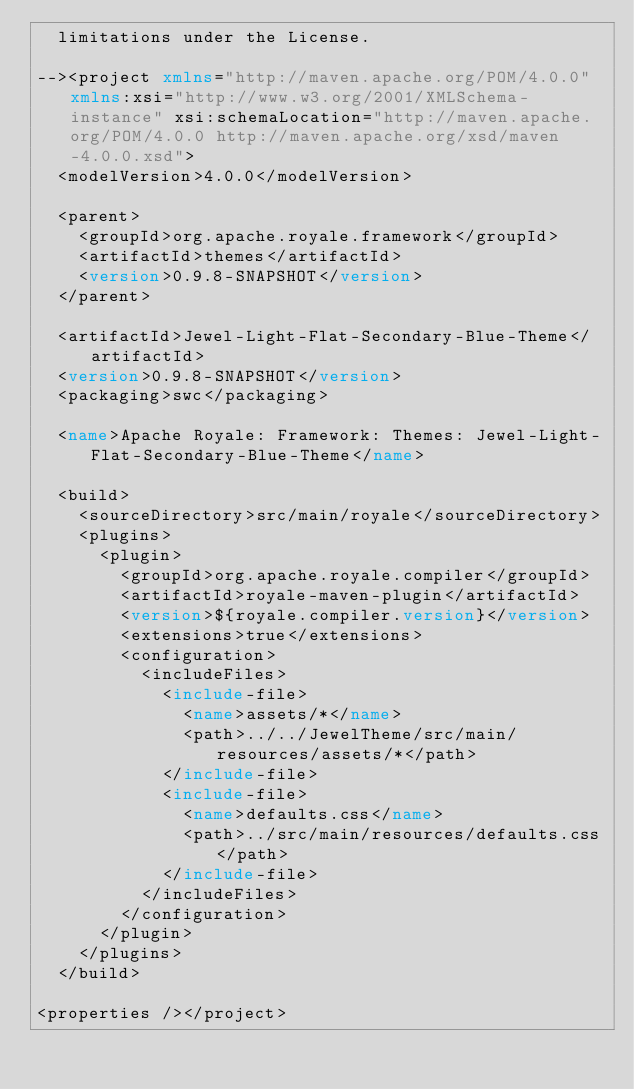<code> <loc_0><loc_0><loc_500><loc_500><_XML_>  limitations under the License.

--><project xmlns="http://maven.apache.org/POM/4.0.0" xmlns:xsi="http://www.w3.org/2001/XMLSchema-instance" xsi:schemaLocation="http://maven.apache.org/POM/4.0.0 http://maven.apache.org/xsd/maven-4.0.0.xsd">
  <modelVersion>4.0.0</modelVersion>

  <parent>
    <groupId>org.apache.royale.framework</groupId>
    <artifactId>themes</artifactId>
    <version>0.9.8-SNAPSHOT</version>
  </parent>

  <artifactId>Jewel-Light-Flat-Secondary-Blue-Theme</artifactId>
  <version>0.9.8-SNAPSHOT</version>
  <packaging>swc</packaging>

  <name>Apache Royale: Framework: Themes: Jewel-Light-Flat-Secondary-Blue-Theme</name>

  <build>
    <sourceDirectory>src/main/royale</sourceDirectory>
    <plugins>
      <plugin>
        <groupId>org.apache.royale.compiler</groupId>
        <artifactId>royale-maven-plugin</artifactId>
        <version>${royale.compiler.version}</version>
        <extensions>true</extensions>
        <configuration>
          <includeFiles>
            <include-file>
              <name>assets/*</name>
              <path>../../JewelTheme/src/main/resources/assets/*</path>
            </include-file>
            <include-file>
              <name>defaults.css</name>
              <path>../src/main/resources/defaults.css</path>
            </include-file>
          </includeFiles>
        </configuration>
      </plugin>
    </plugins>
  </build>

<properties /></project>
</code> 